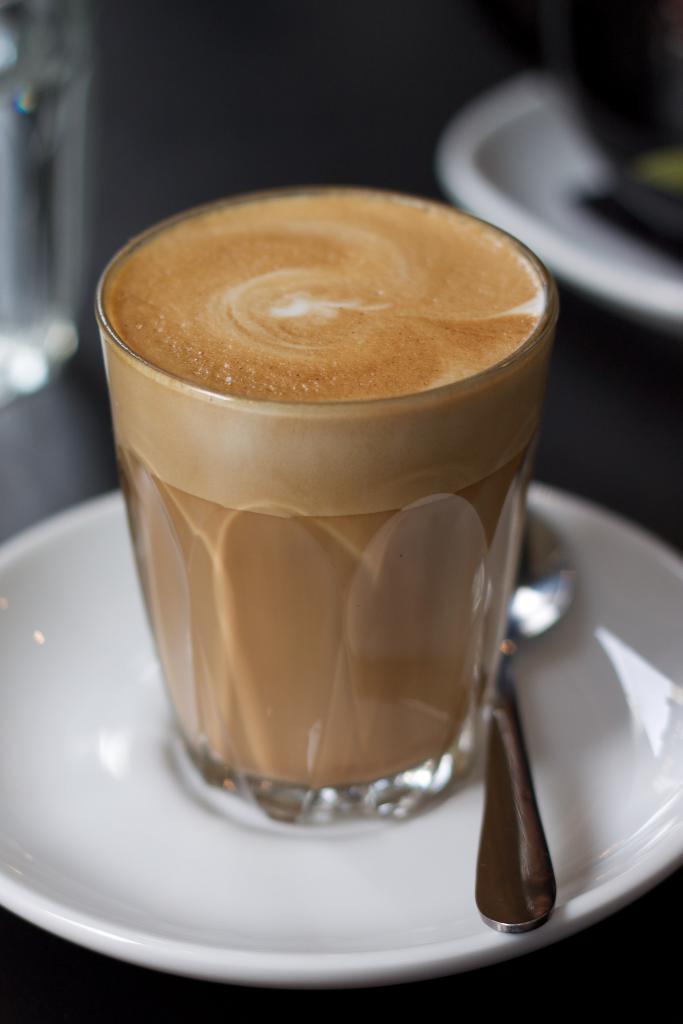Describe this image in one or two sentences. In this image in the foreground there is one saucer cup and spoon and in the cup there is coffee, in the background there is another saucer. 